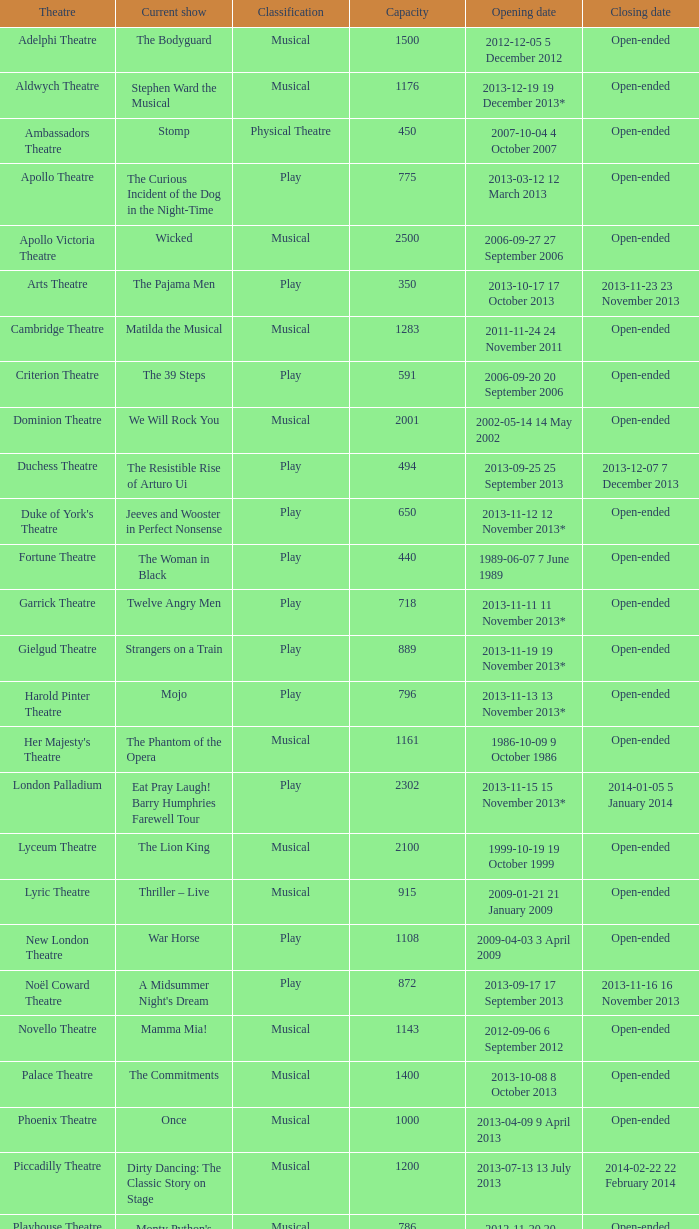What is the opening date of the musical at the adelphi theatre? 2012-12-05 5 December 2012. 